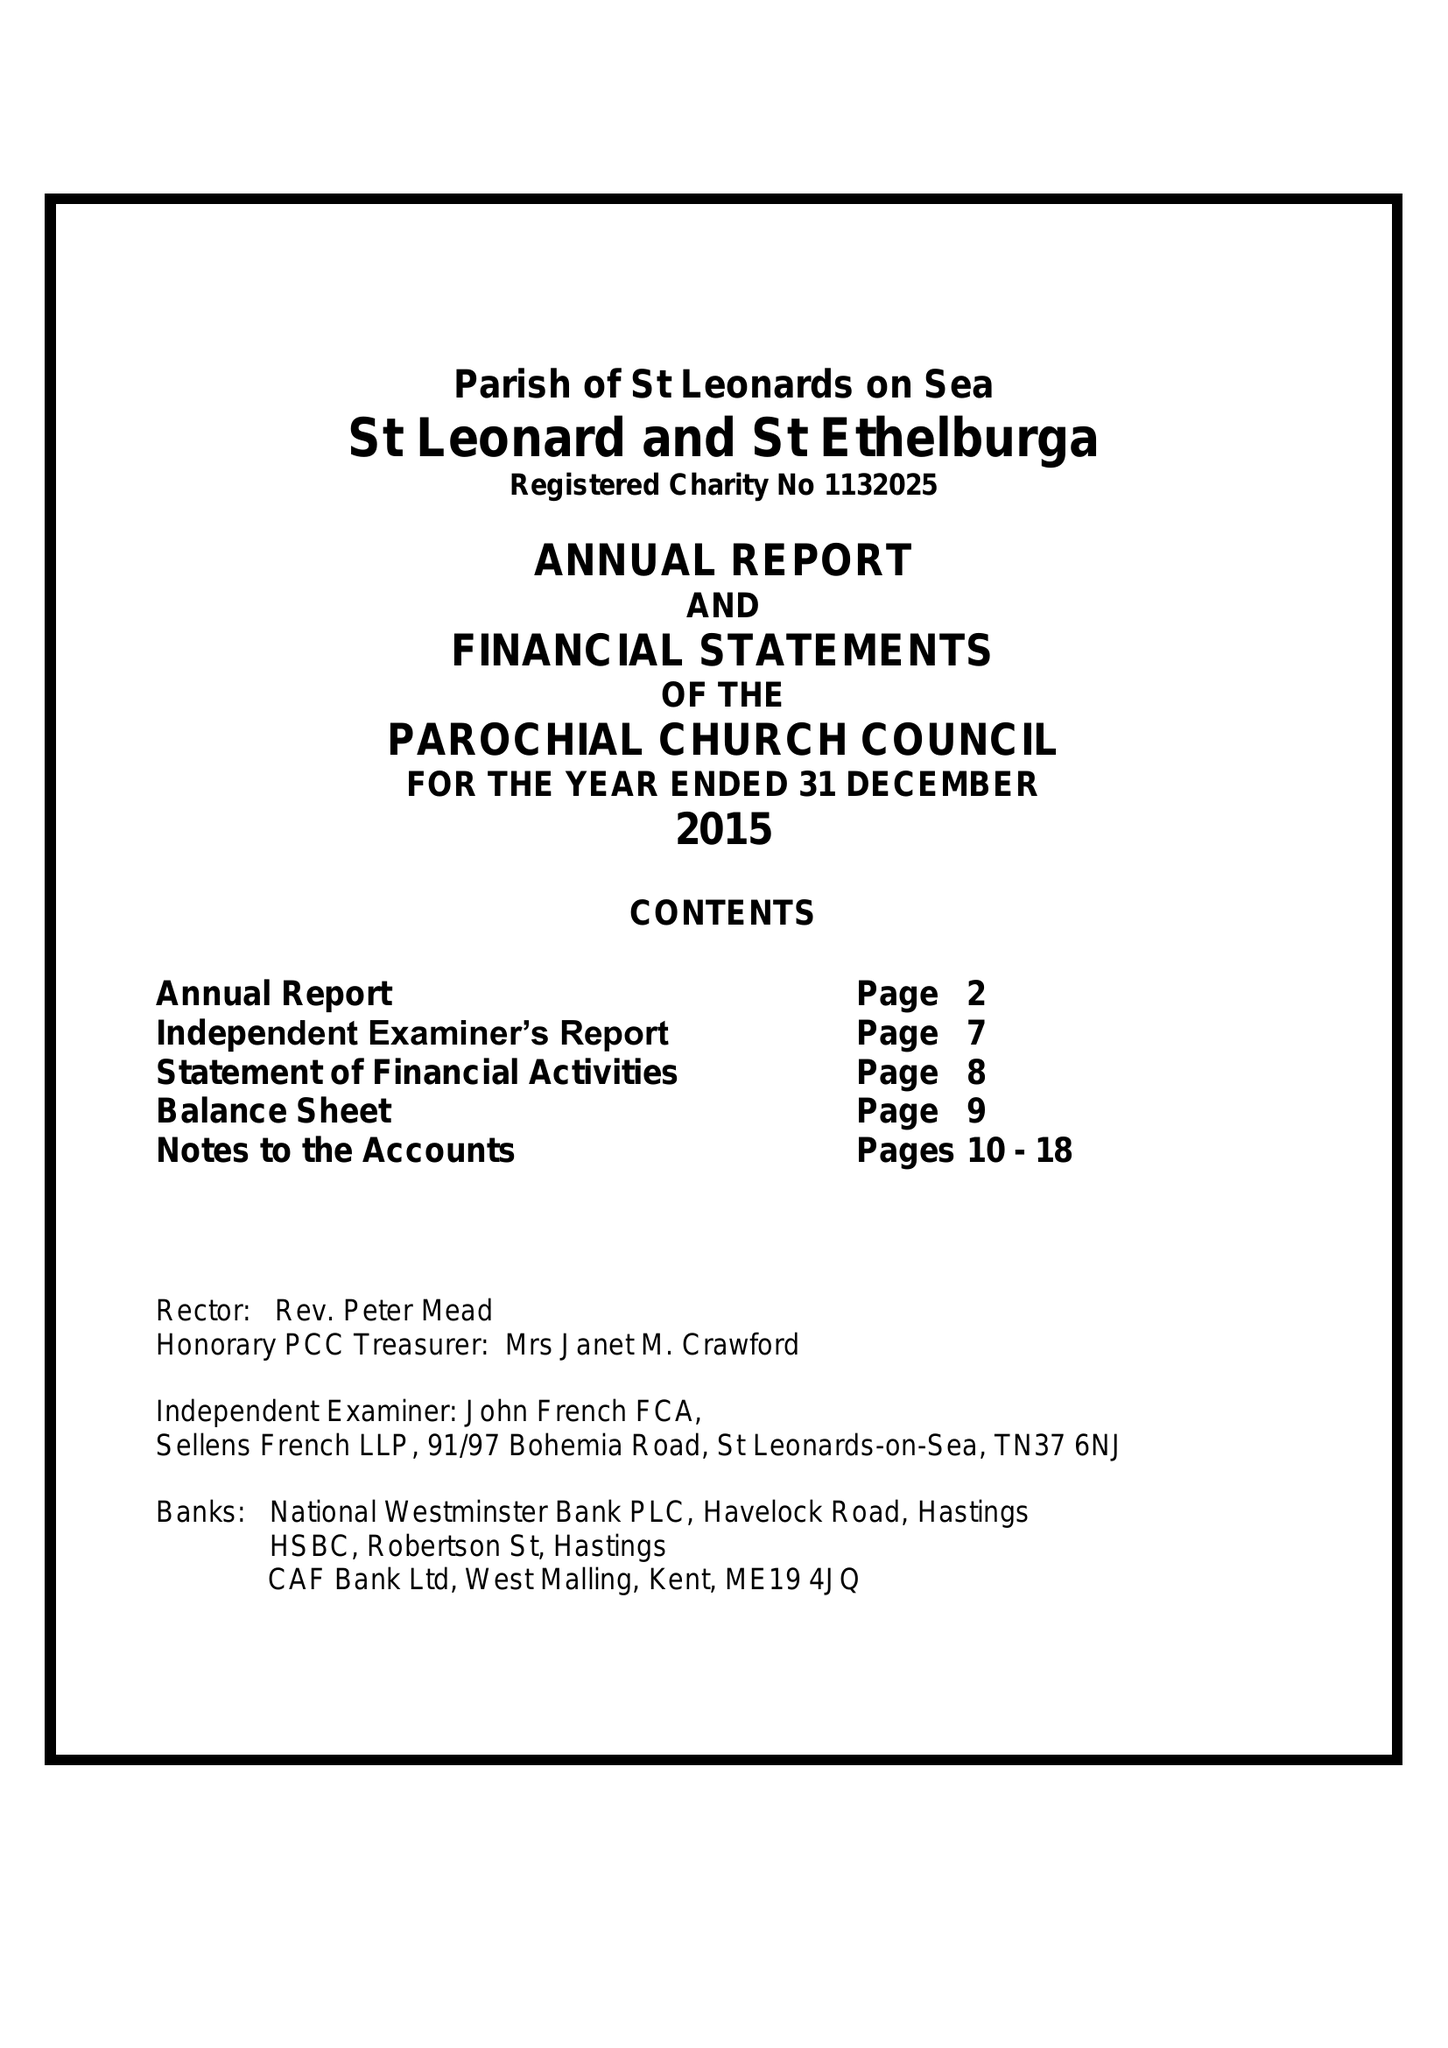What is the value for the address__post_town?
Answer the question using a single word or phrase. ST. LEONARDS-ON-SEA 